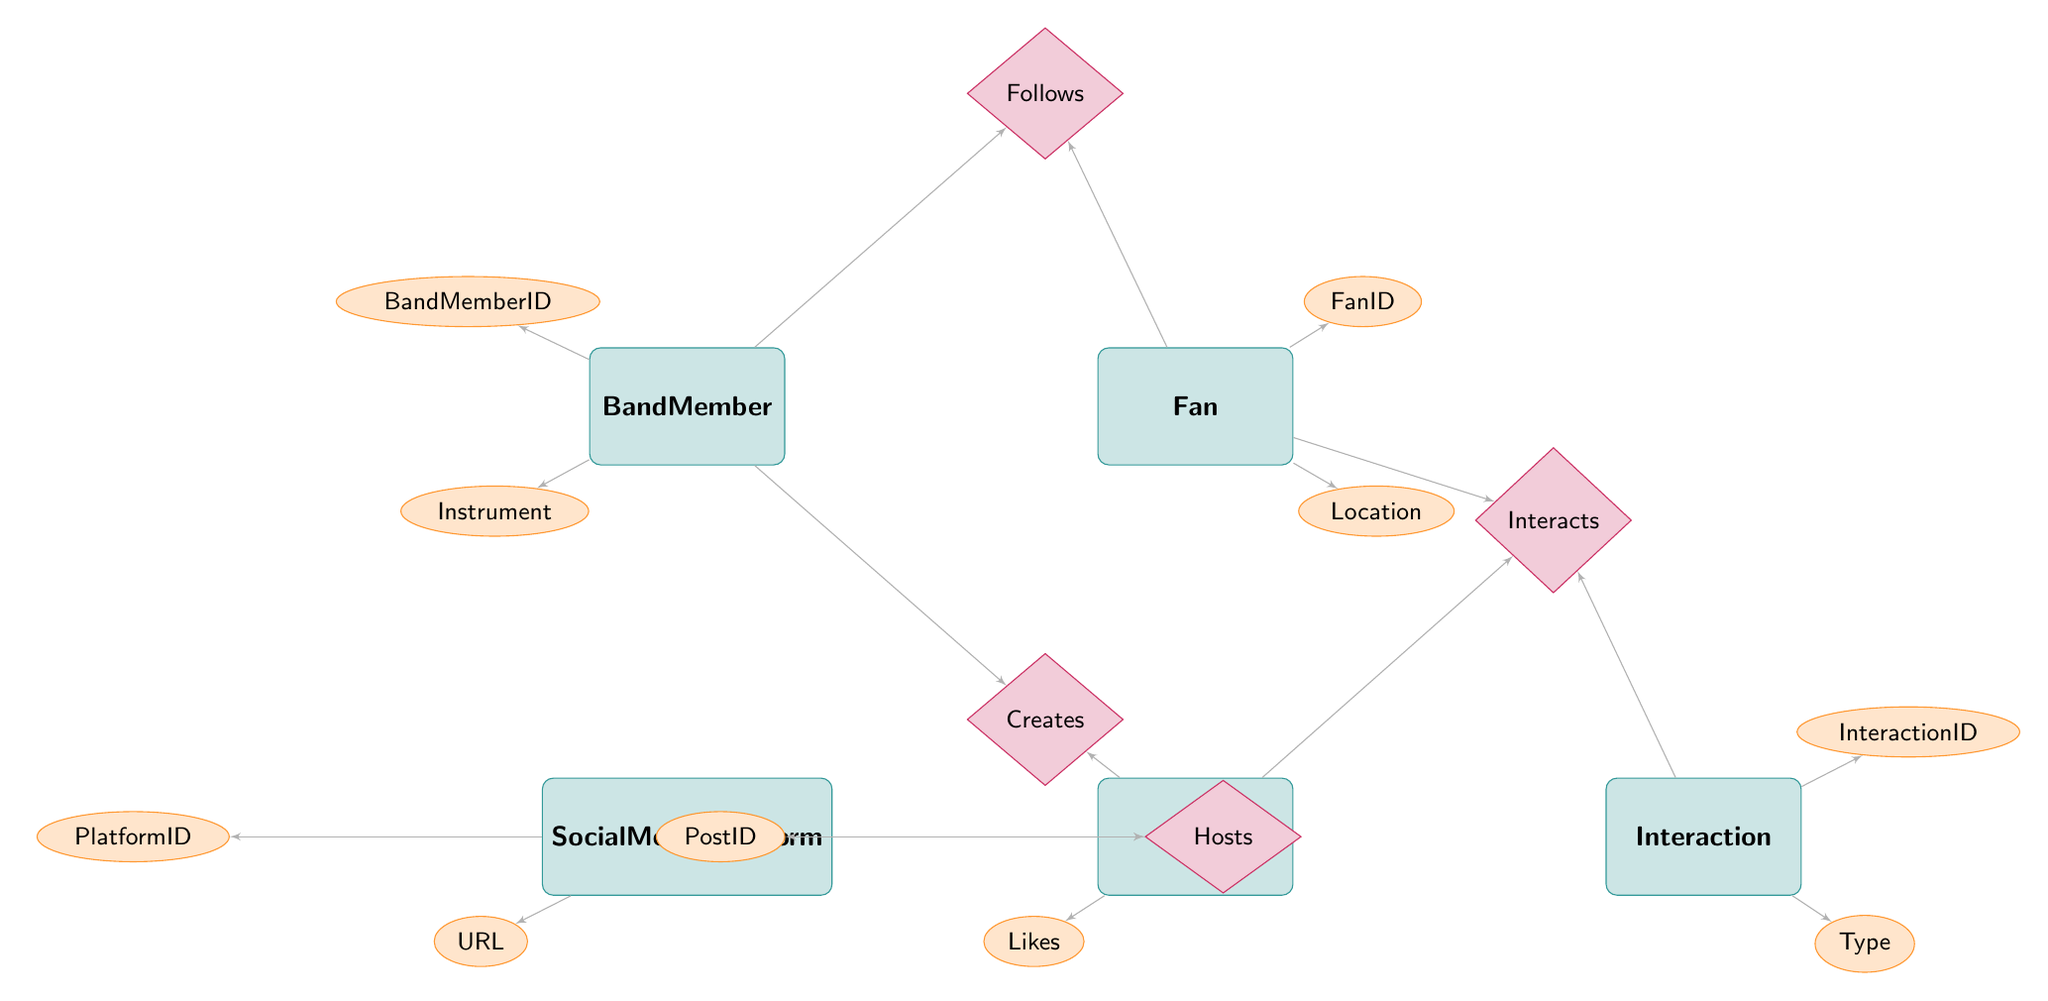What are the entities in the diagram? The diagram contains five entities: BandMember, Fan, SocialMediaPlatform, Post, and Interaction. These can be identified as the main rectangles representing different concepts in the entity relationship.
Answer: BandMember, Fan, SocialMediaPlatform, Post, Interaction How many attributes does the Fan entity have? The Fan entity has four attributes: FanID, Name, Email, and Location. This is determined by counting the ellipses connected to the Fan entity in the diagram.
Answer: 4 What type of relationship exists between Fan and BandMember? The relationship type connecting Fan and BandMember is "Follows." This is identified by observing the diamond shape labeled with this relationship between the respective entities.
Answer: Follows What entity is connected to the Post entity through the relationship "Creates"? The relationship "Creates" connects the BandMember entity to the Post entity. This can be seen in the diagram, where the line indicates that BandMember creates posts.
Answer: BandMember How many total relationships are shown in the diagram? The diagram displays four relationships: FanFollows, PlatformHosts, BandMemberCreates, and FanInteractsWithPost. We count the number of diamond shapes representing relationships to find this figure.
Answer: 4 Which entity is associated with the Interaction entity? The Interaction entity is associated with the Fan and Post entities. This is demonstrated by the relationships indicating that a Fan interacts with a Post, where both entities relate to the Interaction.
Answer: Fan, Post What is the relationship between SocialMediaPlatform and Post? The relationship between SocialMediaPlatform and Post is called "Hosts." This is identified by the diamond labeled "Hosts" between these two entities, indicating the connection.
Answer: Hosts What is the primary key attribute of the BandMember entity? The primary key attribute of the BandMember entity is BandMemberID. This can be identified by looking at the attributes listed underneath the BandMember entity in the diagram.
Answer: BandMemberID Which attribute is associated with the Interaction entity? The Interaction entity has two attributes: InteractionID and Type. These attributes are visually connected to the Interaction entity through lines in the diagram.
Answer: InteractionID, Type 